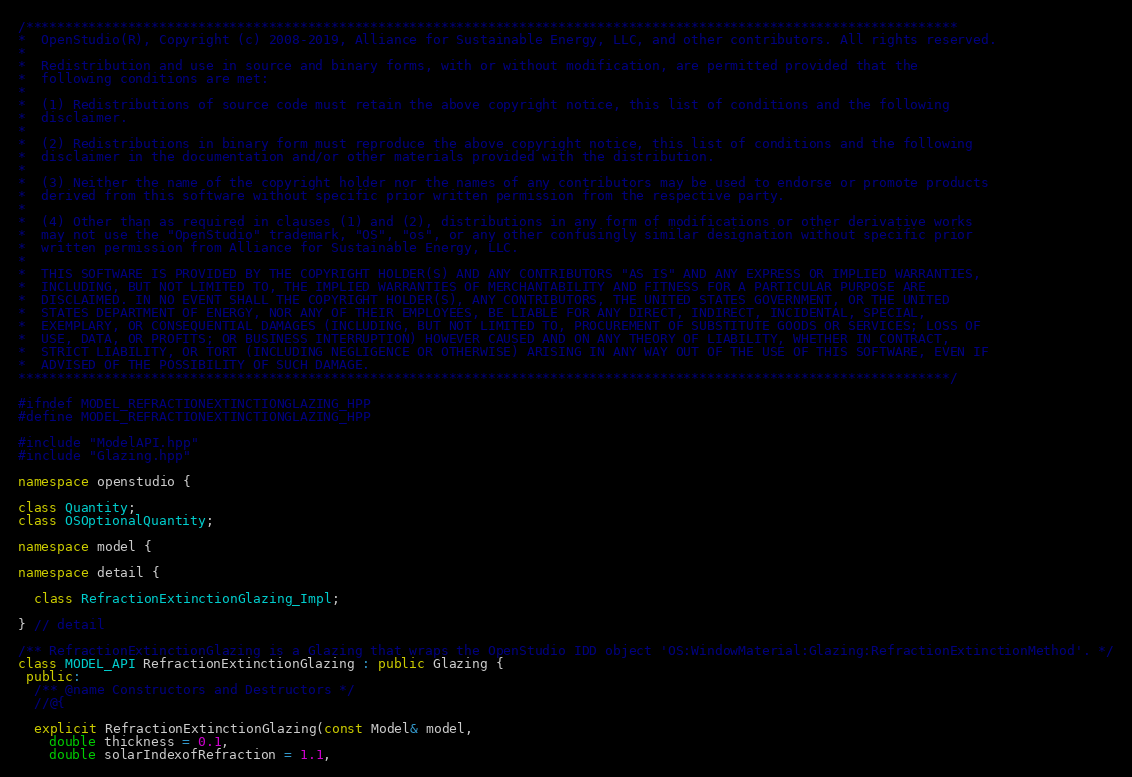Convert code to text. <code><loc_0><loc_0><loc_500><loc_500><_C++_>/***********************************************************************************************************************
*  OpenStudio(R), Copyright (c) 2008-2019, Alliance for Sustainable Energy, LLC, and other contributors. All rights reserved.
*
*  Redistribution and use in source and binary forms, with or without modification, are permitted provided that the
*  following conditions are met:
*
*  (1) Redistributions of source code must retain the above copyright notice, this list of conditions and the following
*  disclaimer.
*
*  (2) Redistributions in binary form must reproduce the above copyright notice, this list of conditions and the following
*  disclaimer in the documentation and/or other materials provided with the distribution.
*
*  (3) Neither the name of the copyright holder nor the names of any contributors may be used to endorse or promote products
*  derived from this software without specific prior written permission from the respective party.
*
*  (4) Other than as required in clauses (1) and (2), distributions in any form of modifications or other derivative works
*  may not use the "OpenStudio" trademark, "OS", "os", or any other confusingly similar designation without specific prior
*  written permission from Alliance for Sustainable Energy, LLC.
*
*  THIS SOFTWARE IS PROVIDED BY THE COPYRIGHT HOLDER(S) AND ANY CONTRIBUTORS "AS IS" AND ANY EXPRESS OR IMPLIED WARRANTIES,
*  INCLUDING, BUT NOT LIMITED TO, THE IMPLIED WARRANTIES OF MERCHANTABILITY AND FITNESS FOR A PARTICULAR PURPOSE ARE
*  DISCLAIMED. IN NO EVENT SHALL THE COPYRIGHT HOLDER(S), ANY CONTRIBUTORS, THE UNITED STATES GOVERNMENT, OR THE UNITED
*  STATES DEPARTMENT OF ENERGY, NOR ANY OF THEIR EMPLOYEES, BE LIABLE FOR ANY DIRECT, INDIRECT, INCIDENTAL, SPECIAL,
*  EXEMPLARY, OR CONSEQUENTIAL DAMAGES (INCLUDING, BUT NOT LIMITED TO, PROCUREMENT OF SUBSTITUTE GOODS OR SERVICES; LOSS OF
*  USE, DATA, OR PROFITS; OR BUSINESS INTERRUPTION) HOWEVER CAUSED AND ON ANY THEORY OF LIABILITY, WHETHER IN CONTRACT,
*  STRICT LIABILITY, OR TORT (INCLUDING NEGLIGENCE OR OTHERWISE) ARISING IN ANY WAY OUT OF THE USE OF THIS SOFTWARE, EVEN IF
*  ADVISED OF THE POSSIBILITY OF SUCH DAMAGE.
***********************************************************************************************************************/

#ifndef MODEL_REFRACTIONEXTINCTIONGLAZING_HPP
#define MODEL_REFRACTIONEXTINCTIONGLAZING_HPP

#include "ModelAPI.hpp"
#include "Glazing.hpp"

namespace openstudio {

class Quantity;
class OSOptionalQuantity;

namespace model {

namespace detail {

  class RefractionExtinctionGlazing_Impl;

} // detail

/** RefractionExtinctionGlazing is a Glazing that wraps the OpenStudio IDD object 'OS:WindowMaterial:Glazing:RefractionExtinctionMethod'. */
class MODEL_API RefractionExtinctionGlazing : public Glazing {
 public:
  /** @name Constructors and Destructors */
  //@{

  explicit RefractionExtinctionGlazing(const Model& model,
    double thickness = 0.1,
    double solarIndexofRefraction = 1.1,</code> 